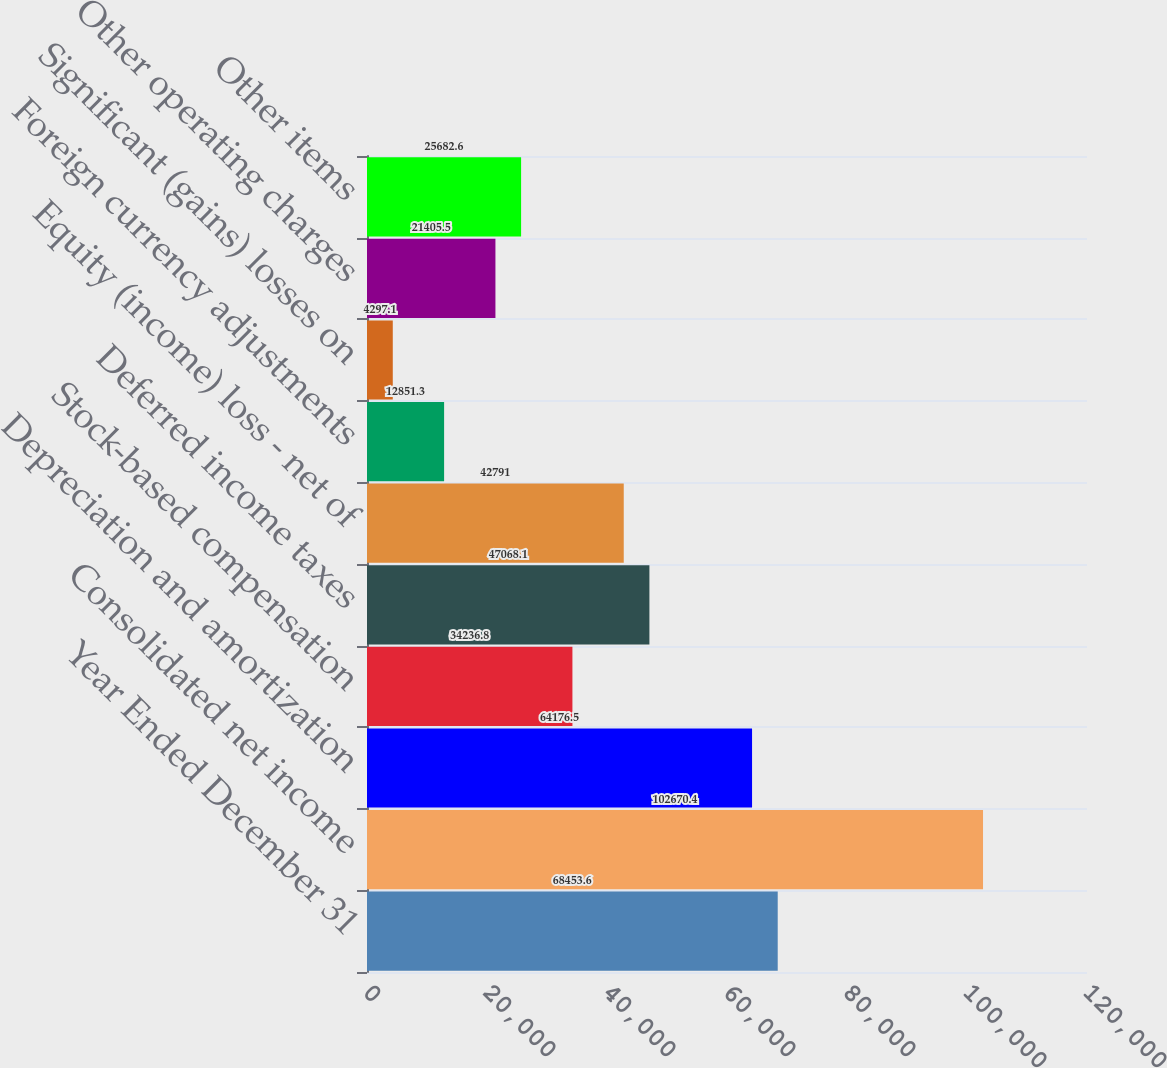Convert chart. <chart><loc_0><loc_0><loc_500><loc_500><bar_chart><fcel>Year Ended December 31<fcel>Consolidated net income<fcel>Depreciation and amortization<fcel>Stock-based compensation<fcel>Deferred income taxes<fcel>Equity (income) loss - net of<fcel>Foreign currency adjustments<fcel>Significant (gains) losses on<fcel>Other operating charges<fcel>Other items<nl><fcel>68453.6<fcel>102670<fcel>64176.5<fcel>34236.8<fcel>47068.1<fcel>42791<fcel>12851.3<fcel>4297.1<fcel>21405.5<fcel>25682.6<nl></chart> 